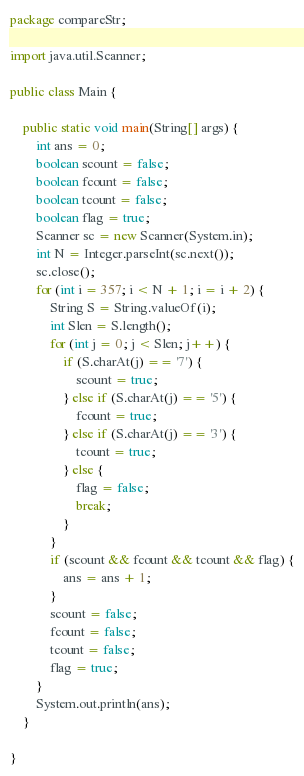Convert code to text. <code><loc_0><loc_0><loc_500><loc_500><_Java_>package compareStr;

import java.util.Scanner;

public class Main {

	public static void main(String[] args) {
		int ans = 0;
		boolean scount = false;
		boolean fcount = false;
		boolean tcount = false;
		boolean flag = true;
		Scanner sc = new Scanner(System.in);
		int N = Integer.parseInt(sc.next());
		sc.close();
		for (int i = 357; i < N + 1; i = i + 2) {
			String S = String.valueOf(i);
			int Slen = S.length();
			for (int j = 0; j < Slen; j++) {
				if (S.charAt(j) == '7') {
					scount = true;
				} else if (S.charAt(j) == '5') {
					fcount = true;
				} else if (S.charAt(j) == '3') {
					tcount = true;
				} else {
					flag = false;
					break;
				}
			}
			if (scount && fcount && tcount && flag) {
				ans = ans + 1;
			}
			scount = false;
			fcount = false;
			tcount = false;
			flag = true;
		}
		System.out.println(ans);
	}

}
</code> 